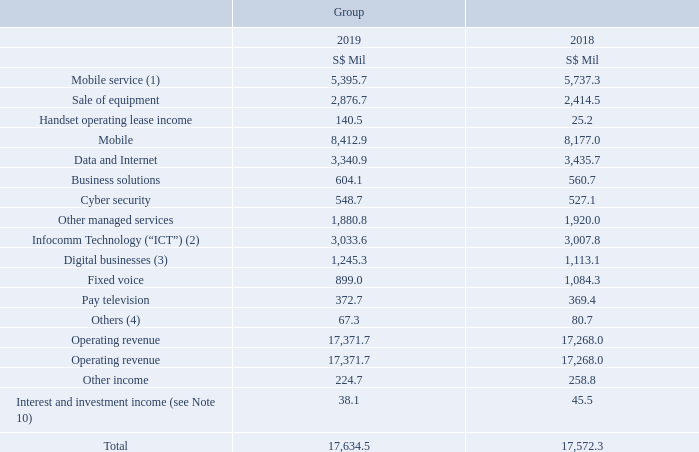Operating Revenue
Notes: (1) Includes revenues from subscription (prepaid/postpaid), interconnect, outbound and inbound roaming, wholesale revenue from MVNOs (Mobile Virtual Network Operators) and mobile content services such as music and video.
(2) Includes equipment sales related to ICT services.
(3) Mainly from provisions of digital marketing and advertising services and regional premium OTT video.
(4) Includes energy reselling fees.
As at 31 March 2019, the transaction price attributable to unsatisfied performance obligations for ICT services rendered by NCS Pte. Ltd. is approximately S$3 billion which will be recognised as operating revenue mostly over the next 5 years.
As at 31 March 2019, the transaction price attributable to unsatisfied performance obligations for ICT services rendered by NCS Pte. Ltd. is approximately S$3 billion which will be recognised as operating revenue mostly over the next 5 years.
Service contracts with consumers typically range from a month to 2 years, and contracts with enterprises typically range from 1 to 3 years.
What is the content of this note 4? Operating revenue. What forms part of the revenue under "Digital Businesses"? Mainly from provisions of digital marketing and advertising services and regional premium ott video. What is the transaction price attributable to unsatisfied performance obligations for ICT services rendered by NCS Pte. Ltd.? S$3 billion. How many streams of revenue are there under operating revenue? Mobile## Data and Internet## Infocomm Technology## Digital Businesses## Fixed voice## Pay television## Others
Answer: 7. How much revenue does the largest 2 sources of revenue streams bring in for Singtel in 2019?
Answer scale should be: million. 8,412.9 + 3,340.9 
Answer: 11753.8. What is the average revenue under "Other income" across the 2 years?
Answer scale should be: million. (224.7 + 258.8) / 2
Answer: 241.75. 